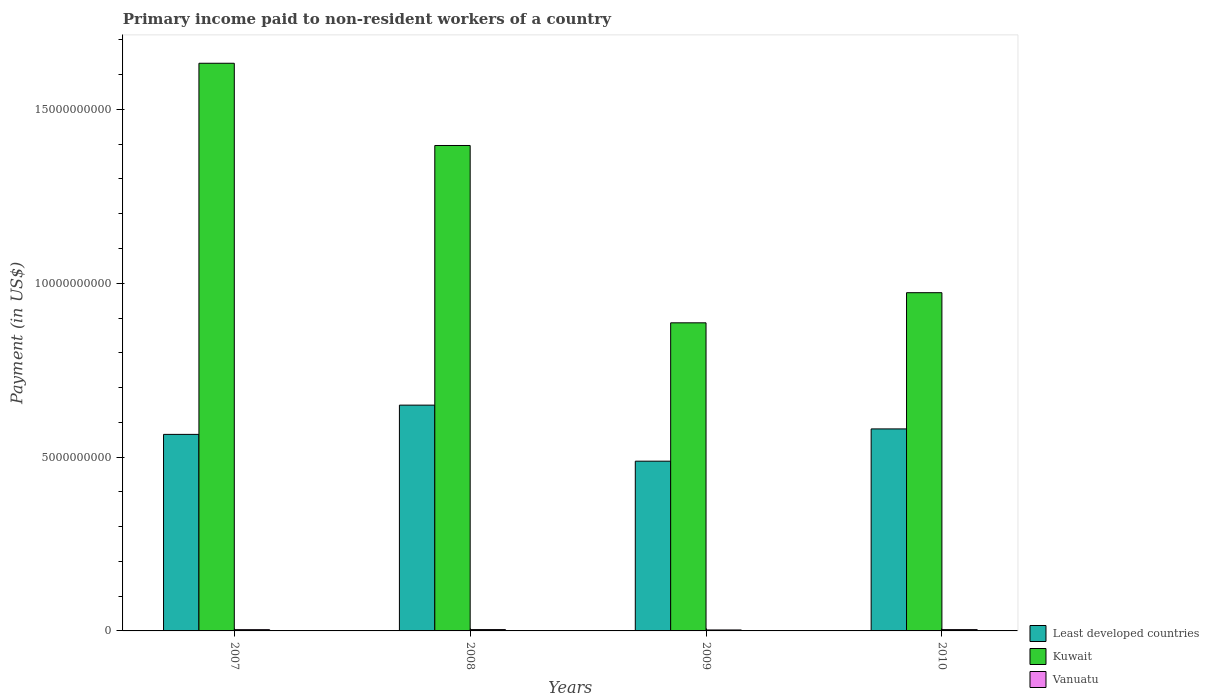How many groups of bars are there?
Provide a short and direct response. 4. Are the number of bars per tick equal to the number of legend labels?
Offer a terse response. Yes. How many bars are there on the 1st tick from the left?
Keep it short and to the point. 3. What is the label of the 1st group of bars from the left?
Your answer should be very brief. 2007. In how many cases, is the number of bars for a given year not equal to the number of legend labels?
Offer a very short reply. 0. What is the amount paid to workers in Kuwait in 2009?
Your answer should be very brief. 8.86e+09. Across all years, what is the maximum amount paid to workers in Vanuatu?
Provide a short and direct response. 3.82e+07. Across all years, what is the minimum amount paid to workers in Kuwait?
Your answer should be compact. 8.86e+09. In which year was the amount paid to workers in Kuwait maximum?
Offer a terse response. 2007. What is the total amount paid to workers in Least developed countries in the graph?
Make the answer very short. 2.28e+1. What is the difference between the amount paid to workers in Kuwait in 2007 and that in 2009?
Your answer should be very brief. 7.47e+09. What is the difference between the amount paid to workers in Vanuatu in 2007 and the amount paid to workers in Least developed countries in 2009?
Your answer should be very brief. -4.85e+09. What is the average amount paid to workers in Least developed countries per year?
Your answer should be very brief. 5.71e+09. In the year 2008, what is the difference between the amount paid to workers in Vanuatu and amount paid to workers in Least developed countries?
Give a very brief answer. -6.46e+09. What is the ratio of the amount paid to workers in Kuwait in 2007 to that in 2008?
Your answer should be very brief. 1.17. Is the difference between the amount paid to workers in Vanuatu in 2009 and 2010 greater than the difference between the amount paid to workers in Least developed countries in 2009 and 2010?
Ensure brevity in your answer.  Yes. What is the difference between the highest and the second highest amount paid to workers in Vanuatu?
Ensure brevity in your answer.  7.41e+05. What is the difference between the highest and the lowest amount paid to workers in Kuwait?
Your response must be concise. 7.47e+09. In how many years, is the amount paid to workers in Vanuatu greater than the average amount paid to workers in Vanuatu taken over all years?
Provide a succinct answer. 3. Is the sum of the amount paid to workers in Least developed countries in 2008 and 2009 greater than the maximum amount paid to workers in Vanuatu across all years?
Make the answer very short. Yes. What does the 3rd bar from the left in 2009 represents?
Your response must be concise. Vanuatu. What does the 2nd bar from the right in 2009 represents?
Make the answer very short. Kuwait. How many bars are there?
Ensure brevity in your answer.  12. Where does the legend appear in the graph?
Your response must be concise. Bottom right. What is the title of the graph?
Give a very brief answer. Primary income paid to non-resident workers of a country. What is the label or title of the Y-axis?
Provide a succinct answer. Payment (in US$). What is the Payment (in US$) of Least developed countries in 2007?
Your answer should be very brief. 5.65e+09. What is the Payment (in US$) in Kuwait in 2007?
Offer a terse response. 1.63e+1. What is the Payment (in US$) in Vanuatu in 2007?
Ensure brevity in your answer.  3.63e+07. What is the Payment (in US$) of Least developed countries in 2008?
Your response must be concise. 6.49e+09. What is the Payment (in US$) of Kuwait in 2008?
Your answer should be compact. 1.40e+1. What is the Payment (in US$) of Vanuatu in 2008?
Make the answer very short. 3.82e+07. What is the Payment (in US$) in Least developed countries in 2009?
Ensure brevity in your answer.  4.88e+09. What is the Payment (in US$) in Kuwait in 2009?
Your answer should be very brief. 8.86e+09. What is the Payment (in US$) in Vanuatu in 2009?
Ensure brevity in your answer.  2.74e+07. What is the Payment (in US$) in Least developed countries in 2010?
Provide a succinct answer. 5.81e+09. What is the Payment (in US$) of Kuwait in 2010?
Your answer should be very brief. 9.73e+09. What is the Payment (in US$) in Vanuatu in 2010?
Your response must be concise. 3.75e+07. Across all years, what is the maximum Payment (in US$) in Least developed countries?
Provide a succinct answer. 6.49e+09. Across all years, what is the maximum Payment (in US$) of Kuwait?
Your answer should be compact. 1.63e+1. Across all years, what is the maximum Payment (in US$) in Vanuatu?
Give a very brief answer. 3.82e+07. Across all years, what is the minimum Payment (in US$) of Least developed countries?
Make the answer very short. 4.88e+09. Across all years, what is the minimum Payment (in US$) in Kuwait?
Provide a short and direct response. 8.86e+09. Across all years, what is the minimum Payment (in US$) in Vanuatu?
Offer a very short reply. 2.74e+07. What is the total Payment (in US$) of Least developed countries in the graph?
Offer a terse response. 2.28e+1. What is the total Payment (in US$) in Kuwait in the graph?
Ensure brevity in your answer.  4.89e+1. What is the total Payment (in US$) of Vanuatu in the graph?
Offer a terse response. 1.39e+08. What is the difference between the Payment (in US$) of Least developed countries in 2007 and that in 2008?
Offer a terse response. -8.42e+08. What is the difference between the Payment (in US$) of Kuwait in 2007 and that in 2008?
Keep it short and to the point. 2.37e+09. What is the difference between the Payment (in US$) of Vanuatu in 2007 and that in 2008?
Offer a terse response. -1.97e+06. What is the difference between the Payment (in US$) of Least developed countries in 2007 and that in 2009?
Your answer should be compact. 7.71e+08. What is the difference between the Payment (in US$) of Kuwait in 2007 and that in 2009?
Your answer should be very brief. 7.47e+09. What is the difference between the Payment (in US$) in Vanuatu in 2007 and that in 2009?
Your answer should be very brief. 8.82e+06. What is the difference between the Payment (in US$) of Least developed countries in 2007 and that in 2010?
Ensure brevity in your answer.  -1.58e+08. What is the difference between the Payment (in US$) of Kuwait in 2007 and that in 2010?
Give a very brief answer. 6.60e+09. What is the difference between the Payment (in US$) in Vanuatu in 2007 and that in 2010?
Give a very brief answer. -1.23e+06. What is the difference between the Payment (in US$) of Least developed countries in 2008 and that in 2009?
Your answer should be compact. 1.61e+09. What is the difference between the Payment (in US$) of Kuwait in 2008 and that in 2009?
Ensure brevity in your answer.  5.10e+09. What is the difference between the Payment (in US$) in Vanuatu in 2008 and that in 2009?
Provide a succinct answer. 1.08e+07. What is the difference between the Payment (in US$) of Least developed countries in 2008 and that in 2010?
Your answer should be very brief. 6.84e+08. What is the difference between the Payment (in US$) of Kuwait in 2008 and that in 2010?
Offer a very short reply. 4.23e+09. What is the difference between the Payment (in US$) in Vanuatu in 2008 and that in 2010?
Your answer should be very brief. 7.41e+05. What is the difference between the Payment (in US$) in Least developed countries in 2009 and that in 2010?
Ensure brevity in your answer.  -9.28e+08. What is the difference between the Payment (in US$) in Kuwait in 2009 and that in 2010?
Give a very brief answer. -8.67e+08. What is the difference between the Payment (in US$) of Vanuatu in 2009 and that in 2010?
Ensure brevity in your answer.  -1.01e+07. What is the difference between the Payment (in US$) of Least developed countries in 2007 and the Payment (in US$) of Kuwait in 2008?
Keep it short and to the point. -8.31e+09. What is the difference between the Payment (in US$) of Least developed countries in 2007 and the Payment (in US$) of Vanuatu in 2008?
Your answer should be very brief. 5.61e+09. What is the difference between the Payment (in US$) in Kuwait in 2007 and the Payment (in US$) in Vanuatu in 2008?
Provide a short and direct response. 1.63e+1. What is the difference between the Payment (in US$) in Least developed countries in 2007 and the Payment (in US$) in Kuwait in 2009?
Offer a very short reply. -3.21e+09. What is the difference between the Payment (in US$) of Least developed countries in 2007 and the Payment (in US$) of Vanuatu in 2009?
Provide a succinct answer. 5.63e+09. What is the difference between the Payment (in US$) in Kuwait in 2007 and the Payment (in US$) in Vanuatu in 2009?
Keep it short and to the point. 1.63e+1. What is the difference between the Payment (in US$) of Least developed countries in 2007 and the Payment (in US$) of Kuwait in 2010?
Your answer should be very brief. -4.08e+09. What is the difference between the Payment (in US$) in Least developed countries in 2007 and the Payment (in US$) in Vanuatu in 2010?
Offer a very short reply. 5.62e+09. What is the difference between the Payment (in US$) of Kuwait in 2007 and the Payment (in US$) of Vanuatu in 2010?
Make the answer very short. 1.63e+1. What is the difference between the Payment (in US$) of Least developed countries in 2008 and the Payment (in US$) of Kuwait in 2009?
Provide a short and direct response. -2.37e+09. What is the difference between the Payment (in US$) of Least developed countries in 2008 and the Payment (in US$) of Vanuatu in 2009?
Provide a short and direct response. 6.47e+09. What is the difference between the Payment (in US$) in Kuwait in 2008 and the Payment (in US$) in Vanuatu in 2009?
Make the answer very short. 1.39e+1. What is the difference between the Payment (in US$) in Least developed countries in 2008 and the Payment (in US$) in Kuwait in 2010?
Your answer should be compact. -3.23e+09. What is the difference between the Payment (in US$) of Least developed countries in 2008 and the Payment (in US$) of Vanuatu in 2010?
Your answer should be compact. 6.46e+09. What is the difference between the Payment (in US$) in Kuwait in 2008 and the Payment (in US$) in Vanuatu in 2010?
Your answer should be very brief. 1.39e+1. What is the difference between the Payment (in US$) of Least developed countries in 2009 and the Payment (in US$) of Kuwait in 2010?
Make the answer very short. -4.85e+09. What is the difference between the Payment (in US$) of Least developed countries in 2009 and the Payment (in US$) of Vanuatu in 2010?
Keep it short and to the point. 4.84e+09. What is the difference between the Payment (in US$) of Kuwait in 2009 and the Payment (in US$) of Vanuatu in 2010?
Make the answer very short. 8.82e+09. What is the average Payment (in US$) of Least developed countries per year?
Keep it short and to the point. 5.71e+09. What is the average Payment (in US$) of Kuwait per year?
Provide a succinct answer. 1.22e+1. What is the average Payment (in US$) of Vanuatu per year?
Give a very brief answer. 3.49e+07. In the year 2007, what is the difference between the Payment (in US$) in Least developed countries and Payment (in US$) in Kuwait?
Your answer should be very brief. -1.07e+1. In the year 2007, what is the difference between the Payment (in US$) in Least developed countries and Payment (in US$) in Vanuatu?
Provide a short and direct response. 5.62e+09. In the year 2007, what is the difference between the Payment (in US$) of Kuwait and Payment (in US$) of Vanuatu?
Make the answer very short. 1.63e+1. In the year 2008, what is the difference between the Payment (in US$) in Least developed countries and Payment (in US$) in Kuwait?
Provide a short and direct response. -7.47e+09. In the year 2008, what is the difference between the Payment (in US$) of Least developed countries and Payment (in US$) of Vanuatu?
Your response must be concise. 6.46e+09. In the year 2008, what is the difference between the Payment (in US$) in Kuwait and Payment (in US$) in Vanuatu?
Your response must be concise. 1.39e+1. In the year 2009, what is the difference between the Payment (in US$) of Least developed countries and Payment (in US$) of Kuwait?
Ensure brevity in your answer.  -3.98e+09. In the year 2009, what is the difference between the Payment (in US$) of Least developed countries and Payment (in US$) of Vanuatu?
Ensure brevity in your answer.  4.85e+09. In the year 2009, what is the difference between the Payment (in US$) of Kuwait and Payment (in US$) of Vanuatu?
Your answer should be very brief. 8.83e+09. In the year 2010, what is the difference between the Payment (in US$) in Least developed countries and Payment (in US$) in Kuwait?
Ensure brevity in your answer.  -3.92e+09. In the year 2010, what is the difference between the Payment (in US$) in Least developed countries and Payment (in US$) in Vanuatu?
Make the answer very short. 5.77e+09. In the year 2010, what is the difference between the Payment (in US$) in Kuwait and Payment (in US$) in Vanuatu?
Keep it short and to the point. 9.69e+09. What is the ratio of the Payment (in US$) of Least developed countries in 2007 to that in 2008?
Ensure brevity in your answer.  0.87. What is the ratio of the Payment (in US$) in Kuwait in 2007 to that in 2008?
Offer a terse response. 1.17. What is the ratio of the Payment (in US$) in Vanuatu in 2007 to that in 2008?
Ensure brevity in your answer.  0.95. What is the ratio of the Payment (in US$) in Least developed countries in 2007 to that in 2009?
Keep it short and to the point. 1.16. What is the ratio of the Payment (in US$) of Kuwait in 2007 to that in 2009?
Ensure brevity in your answer.  1.84. What is the ratio of the Payment (in US$) of Vanuatu in 2007 to that in 2009?
Your answer should be compact. 1.32. What is the ratio of the Payment (in US$) of Least developed countries in 2007 to that in 2010?
Give a very brief answer. 0.97. What is the ratio of the Payment (in US$) in Kuwait in 2007 to that in 2010?
Offer a terse response. 1.68. What is the ratio of the Payment (in US$) of Vanuatu in 2007 to that in 2010?
Ensure brevity in your answer.  0.97. What is the ratio of the Payment (in US$) in Least developed countries in 2008 to that in 2009?
Ensure brevity in your answer.  1.33. What is the ratio of the Payment (in US$) in Kuwait in 2008 to that in 2009?
Ensure brevity in your answer.  1.58. What is the ratio of the Payment (in US$) of Vanuatu in 2008 to that in 2009?
Provide a succinct answer. 1.39. What is the ratio of the Payment (in US$) of Least developed countries in 2008 to that in 2010?
Your response must be concise. 1.12. What is the ratio of the Payment (in US$) of Kuwait in 2008 to that in 2010?
Keep it short and to the point. 1.44. What is the ratio of the Payment (in US$) of Vanuatu in 2008 to that in 2010?
Ensure brevity in your answer.  1.02. What is the ratio of the Payment (in US$) of Least developed countries in 2009 to that in 2010?
Ensure brevity in your answer.  0.84. What is the ratio of the Payment (in US$) in Kuwait in 2009 to that in 2010?
Keep it short and to the point. 0.91. What is the ratio of the Payment (in US$) of Vanuatu in 2009 to that in 2010?
Your answer should be very brief. 0.73. What is the difference between the highest and the second highest Payment (in US$) in Least developed countries?
Provide a short and direct response. 6.84e+08. What is the difference between the highest and the second highest Payment (in US$) in Kuwait?
Provide a short and direct response. 2.37e+09. What is the difference between the highest and the second highest Payment (in US$) in Vanuatu?
Provide a succinct answer. 7.41e+05. What is the difference between the highest and the lowest Payment (in US$) of Least developed countries?
Make the answer very short. 1.61e+09. What is the difference between the highest and the lowest Payment (in US$) of Kuwait?
Offer a terse response. 7.47e+09. What is the difference between the highest and the lowest Payment (in US$) in Vanuatu?
Your answer should be very brief. 1.08e+07. 